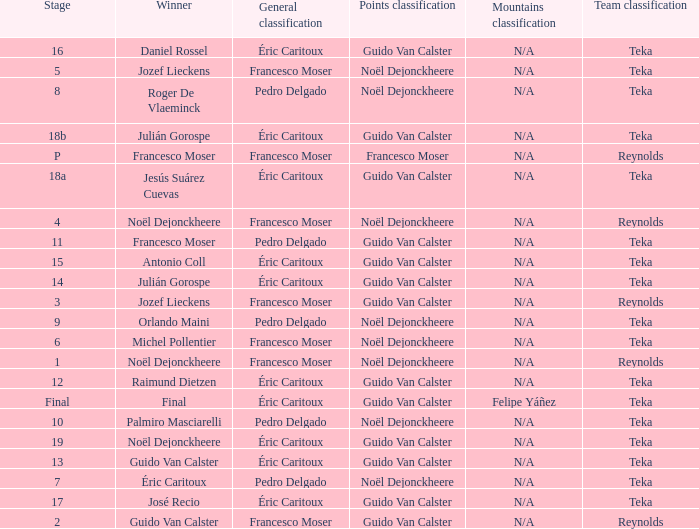Name the points classification for stage of 18b Guido Van Calster. Would you be able to parse every entry in this table? {'header': ['Stage', 'Winner', 'General classification', 'Points classification', 'Mountains classification', 'Team classification'], 'rows': [['16', 'Daniel Rossel', 'Éric Caritoux', 'Guido Van Calster', 'N/A', 'Teka'], ['5', 'Jozef Lieckens', 'Francesco Moser', 'Noël Dejonckheere', 'N/A', 'Teka'], ['8', 'Roger De Vlaeminck', 'Pedro Delgado', 'Noël Dejonckheere', 'N/A', 'Teka'], ['18b', 'Julián Gorospe', 'Éric Caritoux', 'Guido Van Calster', 'N/A', 'Teka'], ['P', 'Francesco Moser', 'Francesco Moser', 'Francesco Moser', 'N/A', 'Reynolds'], ['18a', 'Jesús Suárez Cuevas', 'Éric Caritoux', 'Guido Van Calster', 'N/A', 'Teka'], ['4', 'Noël Dejonckheere', 'Francesco Moser', 'Noël Dejonckheere', 'N/A', 'Reynolds'], ['11', 'Francesco Moser', 'Pedro Delgado', 'Guido Van Calster', 'N/A', 'Teka'], ['15', 'Antonio Coll', 'Éric Caritoux', 'Guido Van Calster', 'N/A', 'Teka'], ['14', 'Julián Gorospe', 'Éric Caritoux', 'Guido Van Calster', 'N/A', 'Teka'], ['3', 'Jozef Lieckens', 'Francesco Moser', 'Guido Van Calster', 'N/A', 'Reynolds'], ['9', 'Orlando Maini', 'Pedro Delgado', 'Noël Dejonckheere', 'N/A', 'Teka'], ['6', 'Michel Pollentier', 'Francesco Moser', 'Noël Dejonckheere', 'N/A', 'Teka'], ['1', 'Noël Dejonckheere', 'Francesco Moser', 'Noël Dejonckheere', 'N/A', 'Reynolds'], ['12', 'Raimund Dietzen', 'Éric Caritoux', 'Guido Van Calster', 'N/A', 'Teka'], ['Final', 'Final', 'Éric Caritoux', 'Guido Van Calster', 'Felipe Yáñez', 'Teka'], ['10', 'Palmiro Masciarelli', 'Pedro Delgado', 'Noël Dejonckheere', 'N/A', 'Teka'], ['19', 'Noël Dejonckheere', 'Éric Caritoux', 'Guido Van Calster', 'N/A', 'Teka'], ['13', 'Guido Van Calster', 'Éric Caritoux', 'Guido Van Calster', 'N/A', 'Teka'], ['7', 'Éric Caritoux', 'Pedro Delgado', 'Noël Dejonckheere', 'N/A', 'Teka'], ['17', 'José Recio', 'Éric Caritoux', 'Guido Van Calster', 'N/A', 'Teka'], ['2', 'Guido Van Calster', 'Francesco Moser', 'Guido Van Calster', 'N/A', 'Reynolds']]} 